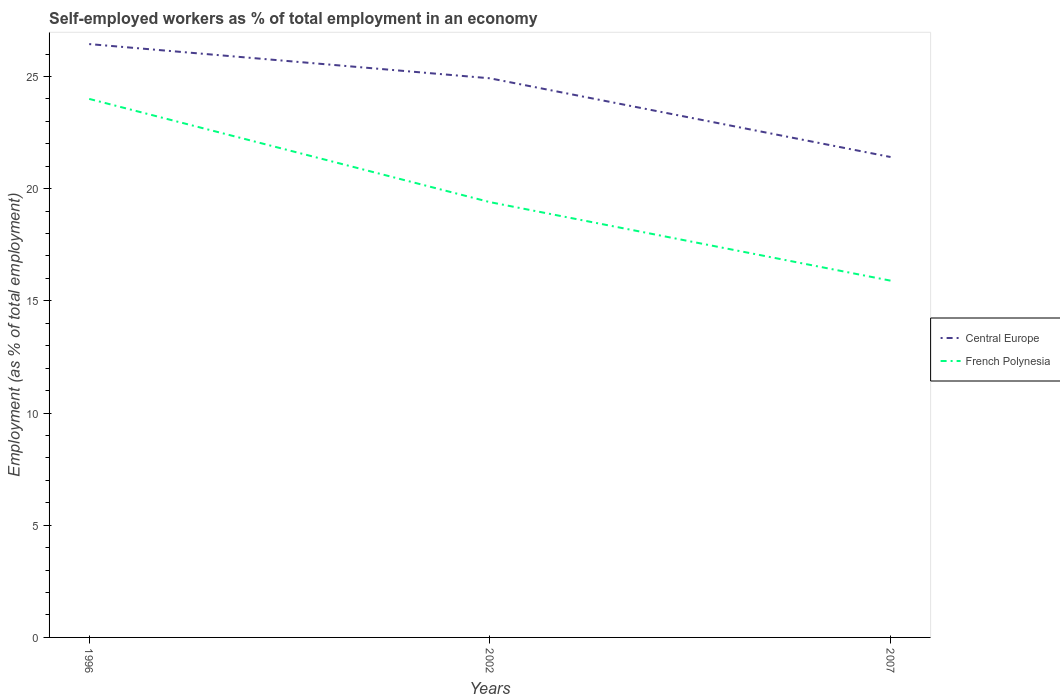Is the number of lines equal to the number of legend labels?
Give a very brief answer. Yes. Across all years, what is the maximum percentage of self-employed workers in Central Europe?
Your answer should be compact. 21.41. What is the total percentage of self-employed workers in French Polynesia in the graph?
Give a very brief answer. 4.6. What is the difference between the highest and the second highest percentage of self-employed workers in Central Europe?
Keep it short and to the point. 5.03. How many lines are there?
Provide a short and direct response. 2. What is the difference between two consecutive major ticks on the Y-axis?
Your answer should be compact. 5. Does the graph contain any zero values?
Make the answer very short. No. Where does the legend appear in the graph?
Your answer should be very brief. Center right. What is the title of the graph?
Your answer should be compact. Self-employed workers as % of total employment in an economy. Does "Macedonia" appear as one of the legend labels in the graph?
Make the answer very short. No. What is the label or title of the Y-axis?
Your response must be concise. Employment (as % of total employment). What is the Employment (as % of total employment) in Central Europe in 1996?
Offer a very short reply. 26.44. What is the Employment (as % of total employment) in Central Europe in 2002?
Give a very brief answer. 24.92. What is the Employment (as % of total employment) in French Polynesia in 2002?
Keep it short and to the point. 19.4. What is the Employment (as % of total employment) in Central Europe in 2007?
Offer a very short reply. 21.41. What is the Employment (as % of total employment) of French Polynesia in 2007?
Provide a short and direct response. 15.9. Across all years, what is the maximum Employment (as % of total employment) of Central Europe?
Provide a succinct answer. 26.44. Across all years, what is the maximum Employment (as % of total employment) of French Polynesia?
Give a very brief answer. 24. Across all years, what is the minimum Employment (as % of total employment) in Central Europe?
Offer a very short reply. 21.41. Across all years, what is the minimum Employment (as % of total employment) in French Polynesia?
Provide a short and direct response. 15.9. What is the total Employment (as % of total employment) of Central Europe in the graph?
Offer a terse response. 72.77. What is the total Employment (as % of total employment) in French Polynesia in the graph?
Keep it short and to the point. 59.3. What is the difference between the Employment (as % of total employment) of Central Europe in 1996 and that in 2002?
Ensure brevity in your answer.  1.52. What is the difference between the Employment (as % of total employment) in French Polynesia in 1996 and that in 2002?
Offer a very short reply. 4.6. What is the difference between the Employment (as % of total employment) of Central Europe in 1996 and that in 2007?
Your answer should be very brief. 5.03. What is the difference between the Employment (as % of total employment) in French Polynesia in 1996 and that in 2007?
Ensure brevity in your answer.  8.1. What is the difference between the Employment (as % of total employment) of Central Europe in 2002 and that in 2007?
Give a very brief answer. 3.51. What is the difference between the Employment (as % of total employment) of French Polynesia in 2002 and that in 2007?
Offer a terse response. 3.5. What is the difference between the Employment (as % of total employment) in Central Europe in 1996 and the Employment (as % of total employment) in French Polynesia in 2002?
Provide a short and direct response. 7.04. What is the difference between the Employment (as % of total employment) of Central Europe in 1996 and the Employment (as % of total employment) of French Polynesia in 2007?
Keep it short and to the point. 10.54. What is the difference between the Employment (as % of total employment) in Central Europe in 2002 and the Employment (as % of total employment) in French Polynesia in 2007?
Provide a succinct answer. 9.02. What is the average Employment (as % of total employment) in Central Europe per year?
Offer a terse response. 24.26. What is the average Employment (as % of total employment) in French Polynesia per year?
Make the answer very short. 19.77. In the year 1996, what is the difference between the Employment (as % of total employment) in Central Europe and Employment (as % of total employment) in French Polynesia?
Offer a terse response. 2.44. In the year 2002, what is the difference between the Employment (as % of total employment) of Central Europe and Employment (as % of total employment) of French Polynesia?
Your answer should be very brief. 5.52. In the year 2007, what is the difference between the Employment (as % of total employment) of Central Europe and Employment (as % of total employment) of French Polynesia?
Provide a succinct answer. 5.51. What is the ratio of the Employment (as % of total employment) of Central Europe in 1996 to that in 2002?
Your answer should be compact. 1.06. What is the ratio of the Employment (as % of total employment) of French Polynesia in 1996 to that in 2002?
Your response must be concise. 1.24. What is the ratio of the Employment (as % of total employment) of Central Europe in 1996 to that in 2007?
Provide a short and direct response. 1.24. What is the ratio of the Employment (as % of total employment) in French Polynesia in 1996 to that in 2007?
Offer a terse response. 1.51. What is the ratio of the Employment (as % of total employment) of Central Europe in 2002 to that in 2007?
Keep it short and to the point. 1.16. What is the ratio of the Employment (as % of total employment) in French Polynesia in 2002 to that in 2007?
Your response must be concise. 1.22. What is the difference between the highest and the second highest Employment (as % of total employment) of Central Europe?
Your answer should be very brief. 1.52. What is the difference between the highest and the second highest Employment (as % of total employment) in French Polynesia?
Your answer should be very brief. 4.6. What is the difference between the highest and the lowest Employment (as % of total employment) of Central Europe?
Give a very brief answer. 5.03. What is the difference between the highest and the lowest Employment (as % of total employment) in French Polynesia?
Your response must be concise. 8.1. 